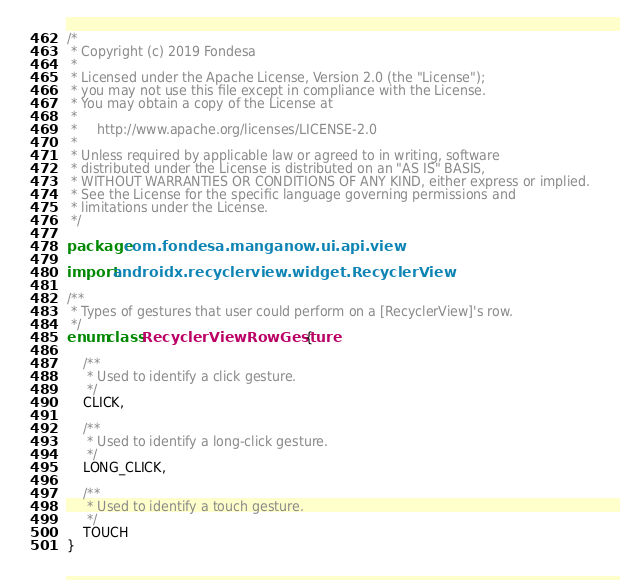Convert code to text. <code><loc_0><loc_0><loc_500><loc_500><_Kotlin_>/*
 * Copyright (c) 2019 Fondesa
 *
 * Licensed under the Apache License, Version 2.0 (the "License");
 * you may not use this file except in compliance with the License.
 * You may obtain a copy of the License at
 *
 *     http://www.apache.org/licenses/LICENSE-2.0
 *
 * Unless required by applicable law or agreed to in writing, software
 * distributed under the License is distributed on an "AS IS" BASIS,
 * WITHOUT WARRANTIES OR CONDITIONS OF ANY KIND, either express or implied.
 * See the License for the specific language governing permissions and
 * limitations under the License.
 */

package com.fondesa.manganow.ui.api.view

import androidx.recyclerview.widget.RecyclerView

/**
 * Types of gestures that user could perform on a [RecyclerView]'s row.
 */
enum class RecyclerViewRowGesture {

    /**
     * Used to identify a click gesture.
     */
    CLICK,

    /**
     * Used to identify a long-click gesture.
     */
    LONG_CLICK,

    /**
     * Used to identify a touch gesture.
     */
    TOUCH
}</code> 